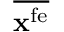Convert formula to latex. <formula><loc_0><loc_0><loc_500><loc_500>\overline { { { x } ^ { f e } } }</formula> 